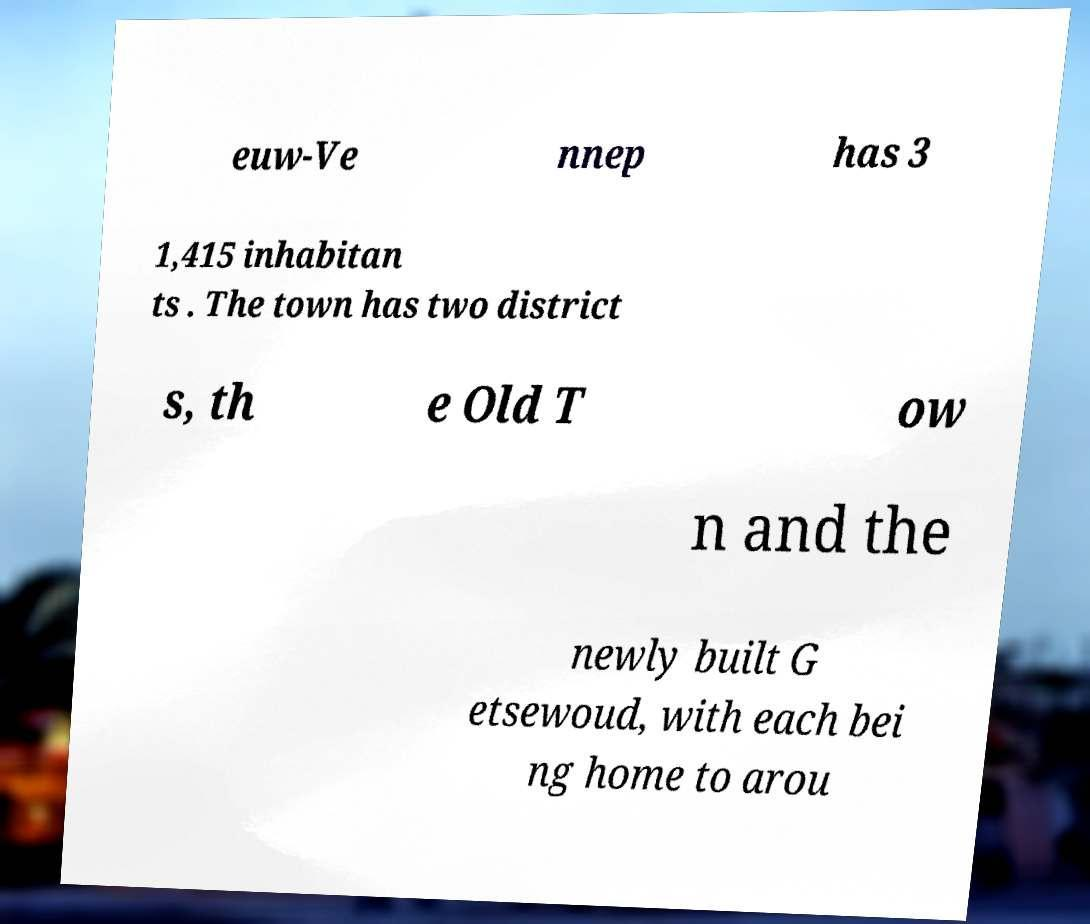There's text embedded in this image that I need extracted. Can you transcribe it verbatim? euw-Ve nnep has 3 1,415 inhabitan ts . The town has two district s, th e Old T ow n and the newly built G etsewoud, with each bei ng home to arou 